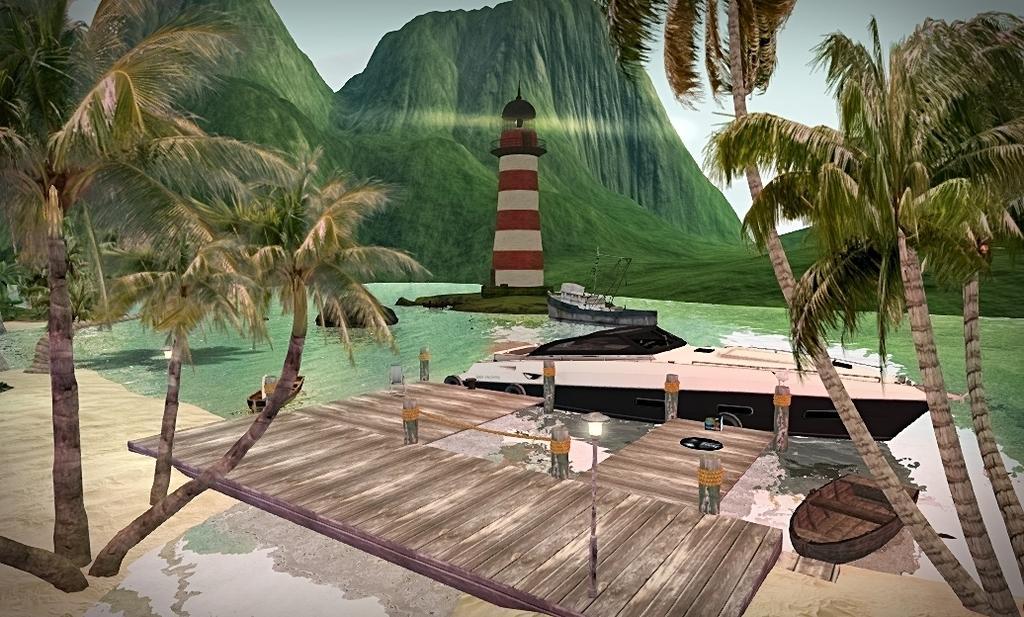Could you give a brief overview of what you see in this image? In this image I can see the painting of tree. To the side of the trees I can see the boat on the water. I can see the light house in the middle of the water. In the background there are mountains and the sky. 